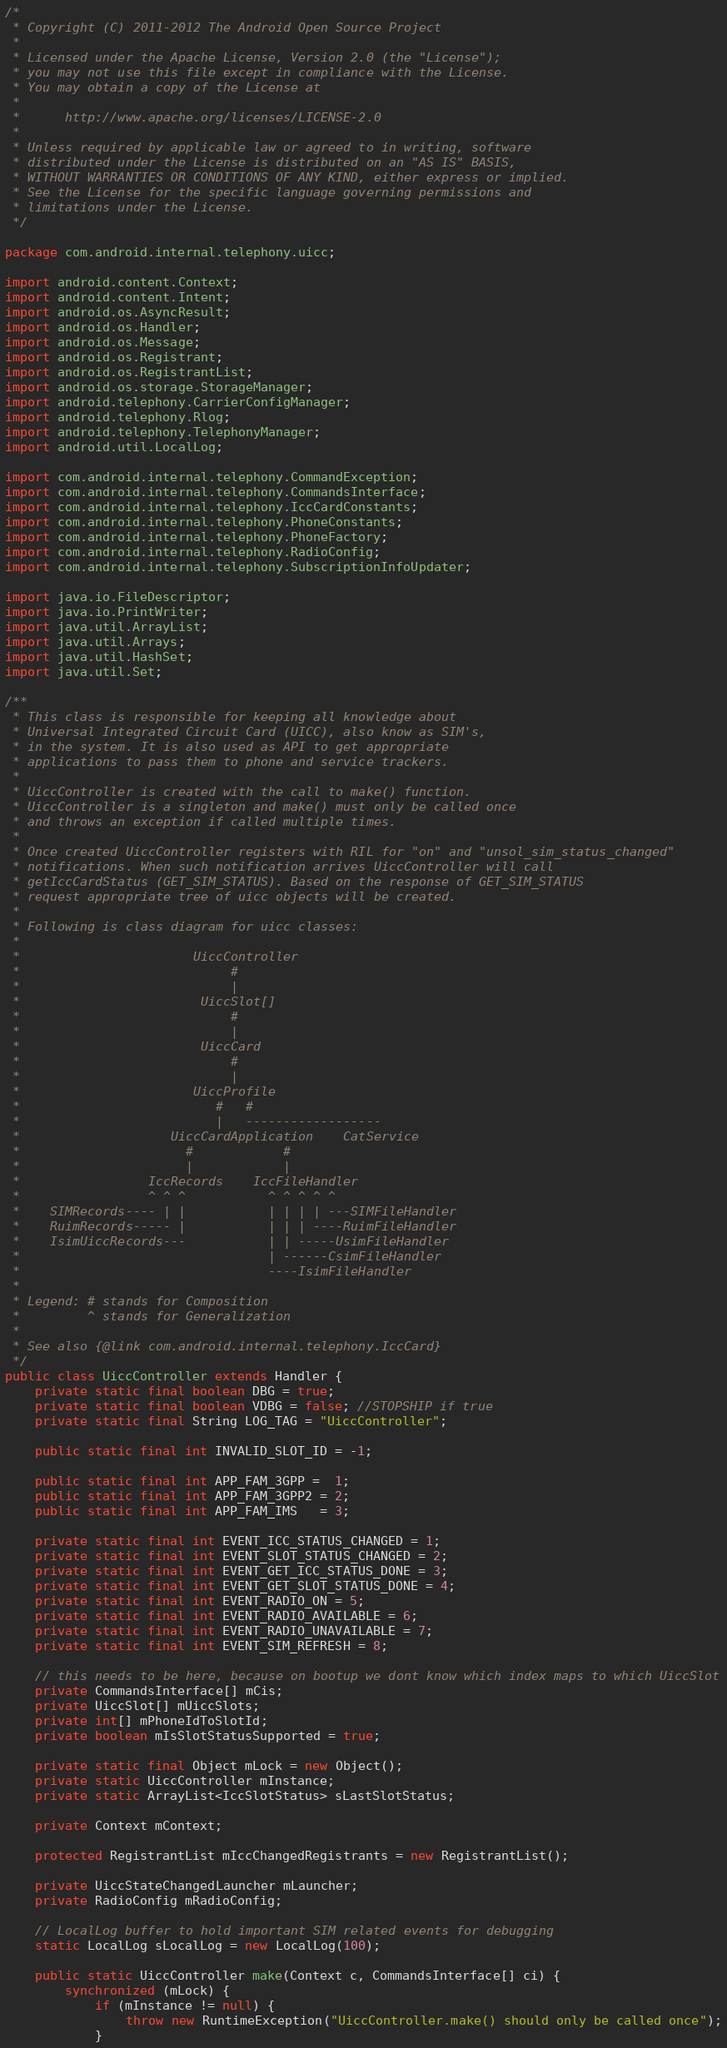<code> <loc_0><loc_0><loc_500><loc_500><_Java_>/*
 * Copyright (C) 2011-2012 The Android Open Source Project
 *
 * Licensed under the Apache License, Version 2.0 (the "License");
 * you may not use this file except in compliance with the License.
 * You may obtain a copy of the License at
 *
 *      http://www.apache.org/licenses/LICENSE-2.0
 *
 * Unless required by applicable law or agreed to in writing, software
 * distributed under the License is distributed on an "AS IS" BASIS,
 * WITHOUT WARRANTIES OR CONDITIONS OF ANY KIND, either express or implied.
 * See the License for the specific language governing permissions and
 * limitations under the License.
 */

package com.android.internal.telephony.uicc;

import android.content.Context;
import android.content.Intent;
import android.os.AsyncResult;
import android.os.Handler;
import android.os.Message;
import android.os.Registrant;
import android.os.RegistrantList;
import android.os.storage.StorageManager;
import android.telephony.CarrierConfigManager;
import android.telephony.Rlog;
import android.telephony.TelephonyManager;
import android.util.LocalLog;

import com.android.internal.telephony.CommandException;
import com.android.internal.telephony.CommandsInterface;
import com.android.internal.telephony.IccCardConstants;
import com.android.internal.telephony.PhoneConstants;
import com.android.internal.telephony.PhoneFactory;
import com.android.internal.telephony.RadioConfig;
import com.android.internal.telephony.SubscriptionInfoUpdater;

import java.io.FileDescriptor;
import java.io.PrintWriter;
import java.util.ArrayList;
import java.util.Arrays;
import java.util.HashSet;
import java.util.Set;

/**
 * This class is responsible for keeping all knowledge about
 * Universal Integrated Circuit Card (UICC), also know as SIM's,
 * in the system. It is also used as API to get appropriate
 * applications to pass them to phone and service trackers.
 *
 * UiccController is created with the call to make() function.
 * UiccController is a singleton and make() must only be called once
 * and throws an exception if called multiple times.
 *
 * Once created UiccController registers with RIL for "on" and "unsol_sim_status_changed"
 * notifications. When such notification arrives UiccController will call
 * getIccCardStatus (GET_SIM_STATUS). Based on the response of GET_SIM_STATUS
 * request appropriate tree of uicc objects will be created.
 *
 * Following is class diagram for uicc classes:
 *
 *                       UiccController
 *                            #
 *                            |
 *                        UiccSlot[]
 *                            #
 *                            |
 *                        UiccCard
 *                            #
 *                            |
 *                       UiccProfile
 *                          #   #
 *                          |   ------------------
 *                    UiccCardApplication    CatService
 *                      #            #
 *                      |            |
 *                 IccRecords    IccFileHandler
 *                 ^ ^ ^           ^ ^ ^ ^ ^
 *    SIMRecords---- | |           | | | | ---SIMFileHandler
 *    RuimRecords----- |           | | | ----RuimFileHandler
 *    IsimUiccRecords---           | | -----UsimFileHandler
 *                                 | ------CsimFileHandler
 *                                 ----IsimFileHandler
 *
 * Legend: # stands for Composition
 *         ^ stands for Generalization
 *
 * See also {@link com.android.internal.telephony.IccCard}
 */
public class UiccController extends Handler {
    private static final boolean DBG = true;
    private static final boolean VDBG = false; //STOPSHIP if true
    private static final String LOG_TAG = "UiccController";

    public static final int INVALID_SLOT_ID = -1;

    public static final int APP_FAM_3GPP =  1;
    public static final int APP_FAM_3GPP2 = 2;
    public static final int APP_FAM_IMS   = 3;

    private static final int EVENT_ICC_STATUS_CHANGED = 1;
    private static final int EVENT_SLOT_STATUS_CHANGED = 2;
    private static final int EVENT_GET_ICC_STATUS_DONE = 3;
    private static final int EVENT_GET_SLOT_STATUS_DONE = 4;
    private static final int EVENT_RADIO_ON = 5;
    private static final int EVENT_RADIO_AVAILABLE = 6;
    private static final int EVENT_RADIO_UNAVAILABLE = 7;
    private static final int EVENT_SIM_REFRESH = 8;

    // this needs to be here, because on bootup we dont know which index maps to which UiccSlot
    private CommandsInterface[] mCis;
    private UiccSlot[] mUiccSlots;
    private int[] mPhoneIdToSlotId;
    private boolean mIsSlotStatusSupported = true;

    private static final Object mLock = new Object();
    private static UiccController mInstance;
    private static ArrayList<IccSlotStatus> sLastSlotStatus;

    private Context mContext;

    protected RegistrantList mIccChangedRegistrants = new RegistrantList();

    private UiccStateChangedLauncher mLauncher;
    private RadioConfig mRadioConfig;

    // LocalLog buffer to hold important SIM related events for debugging
    static LocalLog sLocalLog = new LocalLog(100);

    public static UiccController make(Context c, CommandsInterface[] ci) {
        synchronized (mLock) {
            if (mInstance != null) {
                throw new RuntimeException("UiccController.make() should only be called once");
            }</code> 